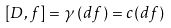<formula> <loc_0><loc_0><loc_500><loc_500>[ D , f ] = \gamma \left ( d f \right ) = c ( d f )</formula> 